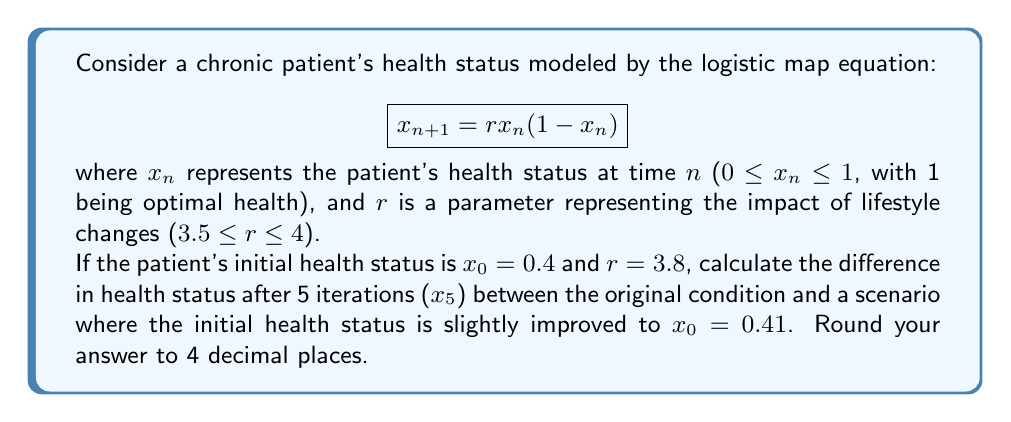Can you solve this math problem? To solve this problem, we need to iterate the logistic map equation for both initial conditions and compare the results after 5 iterations. Let's go through this step-by-step:

1. For $x_0 = 0.4$ and $r = 3.8$:

   $x_1 = 3.8 * 0.4 * (1 - 0.4) = 0.912$
   $x_2 = 3.8 * 0.912 * (1 - 0.912) = 0.3053952$
   $x_3 = 3.8 * 0.3053952 * (1 - 0.3053952) = 0.8062234$
   $x_4 = 3.8 * 0.8062234 * (1 - 0.8062234) = 0.5942339$
   $x_5 = 3.8 * 0.5942339 * (1 - 0.5942339) = 0.9151699$

2. For $x_0 = 0.41$ and $r = 3.8$:

   $x_1 = 3.8 * 0.41 * (1 - 0.41) = 0.9201$
   $x_2 = 3.8 * 0.9201 * (1 - 0.9201) = 0.2799619$
   $x_3 = 3.8 * 0.2799619 * (1 - 0.2799619) = 0.7675251$
   $x_4 = 3.8 * 0.7675251 * (1 - 0.7675251) = 0.6789847$
   $x_5 = 3.8 * 0.6789847 * (1 - 0.6789847) = 0.8281398$

3. Calculate the difference:

   $|0.9151699 - 0.8281398| = 0.0870301$

4. Round to 4 decimal places:

   $0.0870301 ≈ 0.0870$

This significant difference after only 5 iterations, despite a small change in initial conditions, demonstrates the butterfly effect in the patient's health outcomes due to lifestyle changes.
Answer: 0.0870 